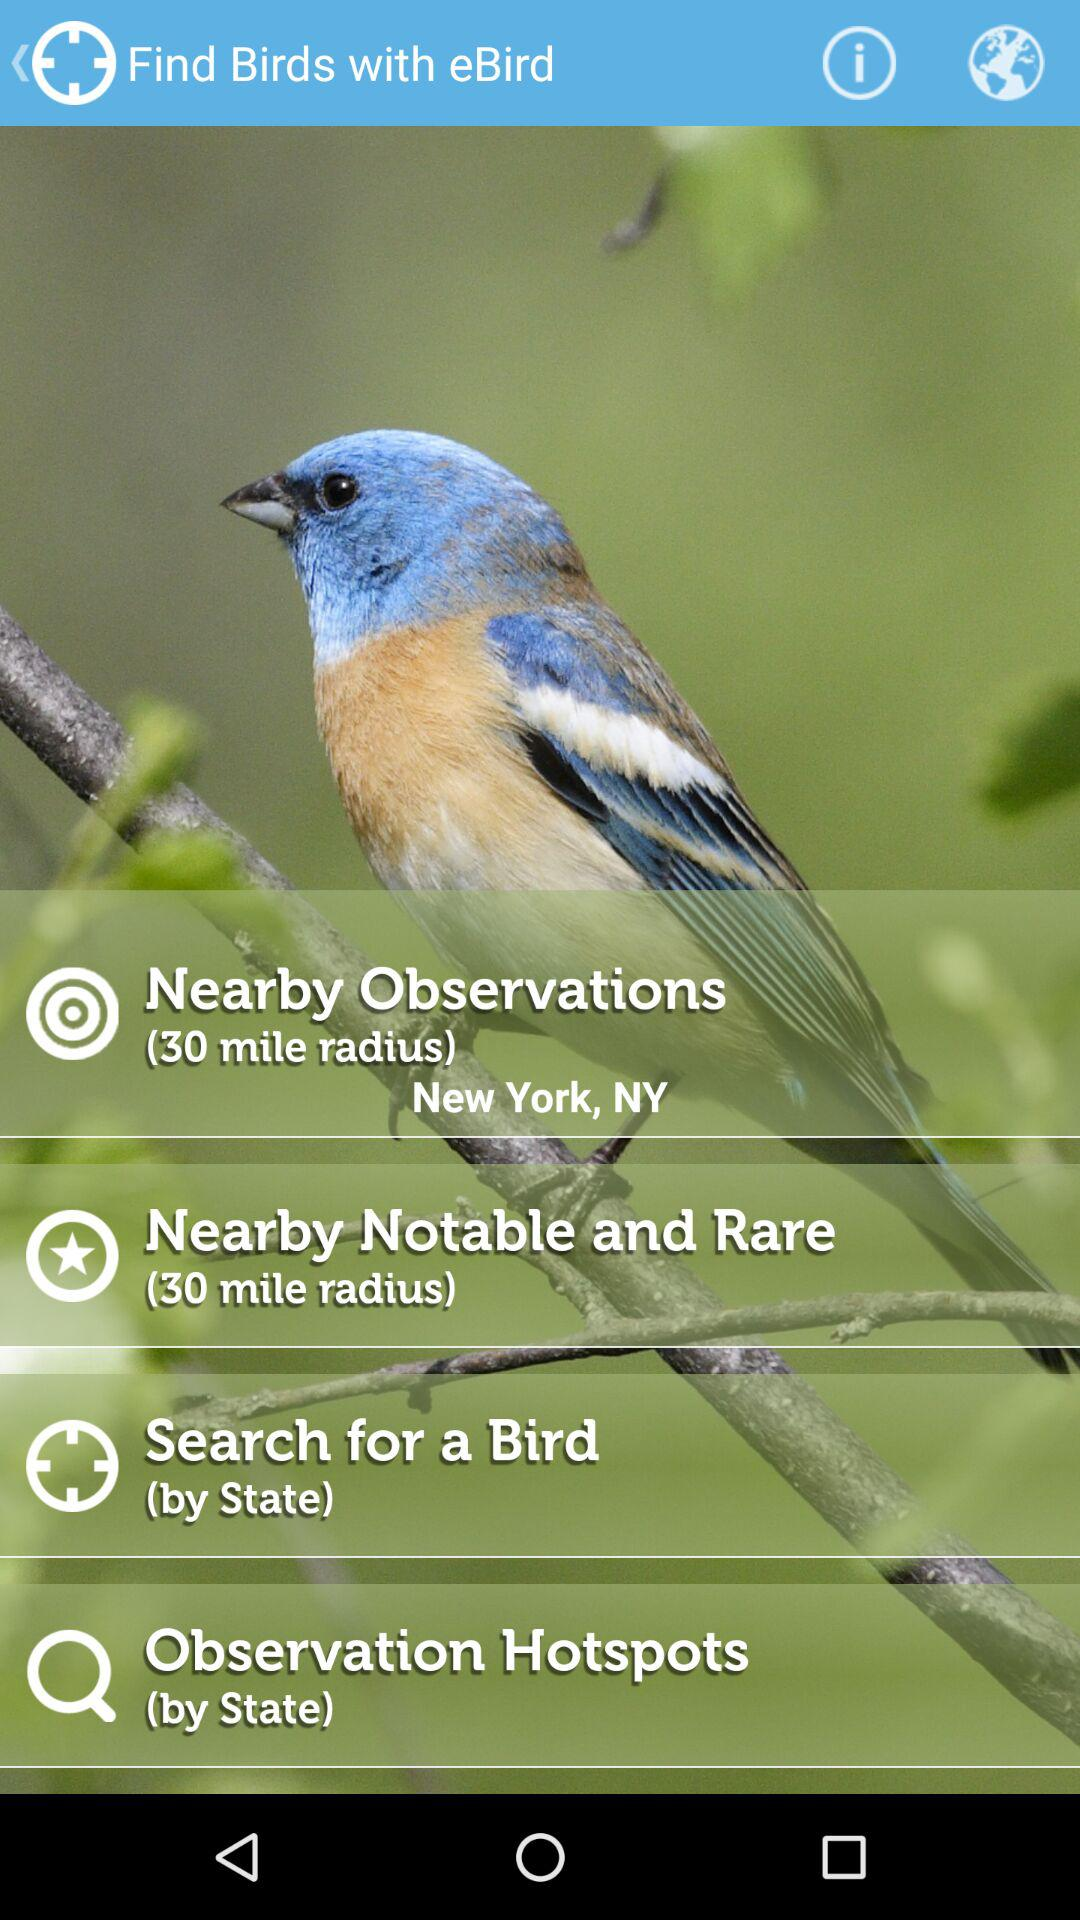For what can the person search? The person can search for a bird. 